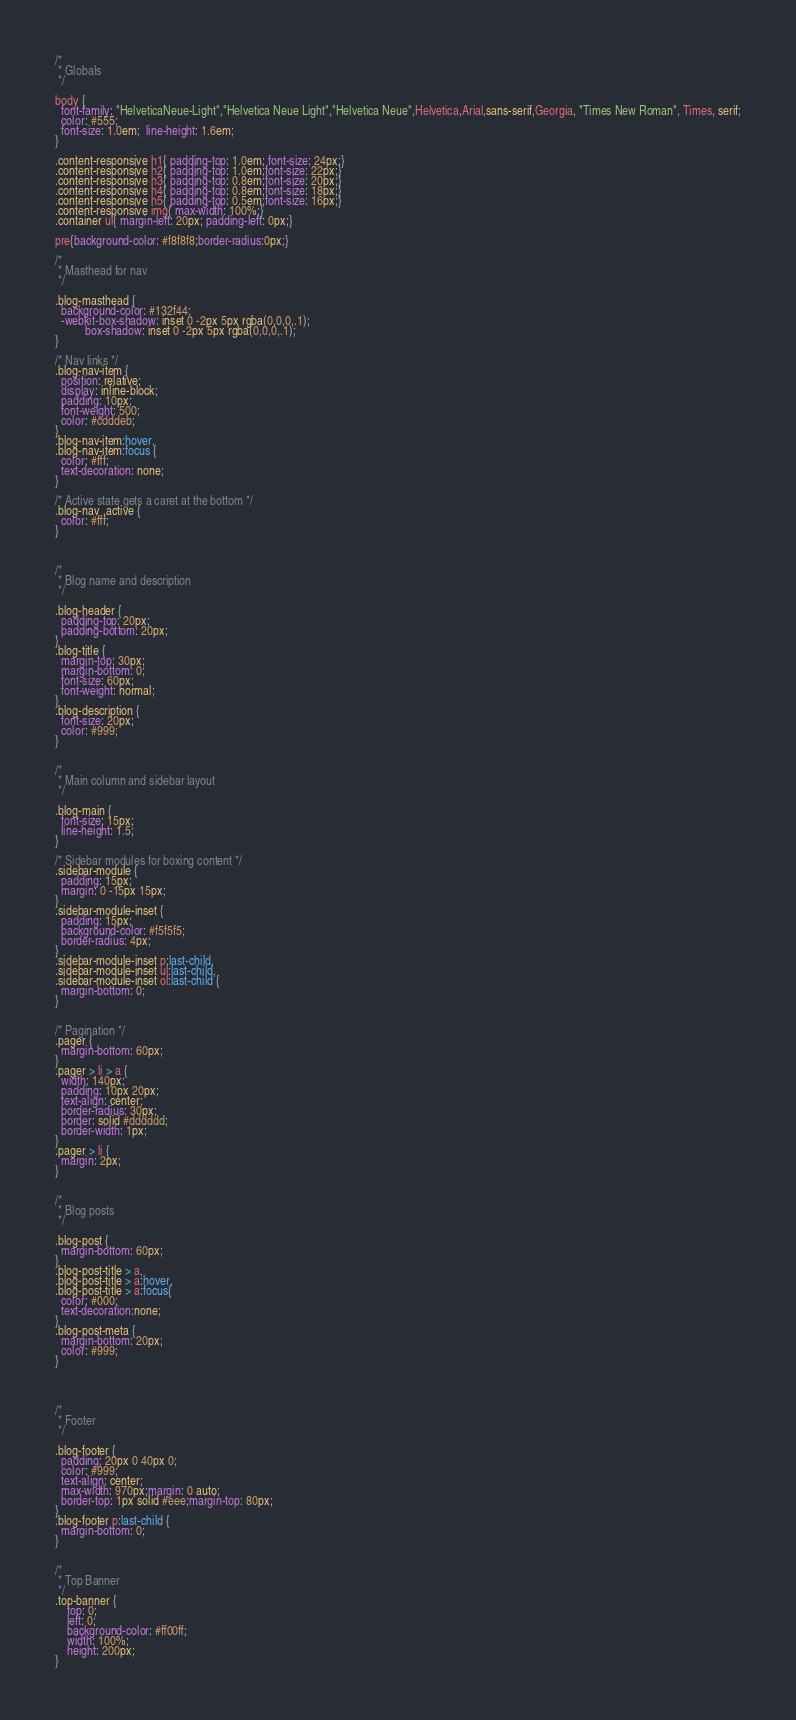<code> <loc_0><loc_0><loc_500><loc_500><_CSS_>
/*
 * Globals
 */

body {
  font-family: "HelveticaNeue-Light","Helvetica Neue Light","Helvetica Neue",Helvetica,Arial,sans-serif,Georgia, "Times New Roman", Times, serif;
  color: #555;
  font-size: 1.0em;  line-height: 1.6em;
}

.content-responsive h1{ padding-top: 1.0em; font-size: 24px;}
.content-responsive h2{ padding-top: 1.0em;font-size: 22px;}
.content-responsive h3{ padding-top: 0.8em;font-size: 20px;}
.content-responsive h4{ padding-top: 0.8em;font-size: 18px;}
.content-responsive h5{ padding-top: 0.5em;font-size: 16px;}
.content-responsive img{ max-width: 100%;}
.container ul{ margin-left: 20px; padding-left: 0px;}

pre{background-color: #f8f8f8;border-radius:0px;}   

/*
 * Masthead for nav
 */

.blog-masthead {
  background-color: #132f44;
  -webkit-box-shadow: inset 0 -2px 5px rgba(0,0,0,.1);
          box-shadow: inset 0 -2px 5px rgba(0,0,0,.1);
}

/* Nav links */
.blog-nav-item {
  position: relative;
  display: inline-block;
  padding: 10px;
  font-weight: 500;
  color: #cdddeb;
}
.blog-nav-item:hover,
.blog-nav-item:focus {
  color: #fff;
  text-decoration: none;
}

/* Active state gets a caret at the bottom */
.blog-nav .active {
  color: #fff;
}



/*
 * Blog name and description
 */

.blog-header {
  padding-top: 20px;
  padding-bottom: 20px;
}
.blog-title {
  margin-top: 30px;
  margin-bottom: 0;
  font-size: 60px;
  font-weight: normal;
}
.blog-description {
  font-size: 20px;
  color: #999;
}


/*
 * Main column and sidebar layout
 */

.blog-main {
  font-size: 15px;
  line-height: 1.5;
}

/* Sidebar modules for boxing content */
.sidebar-module {
  padding: 15px;
  margin: 0 -15px 15px;
}
.sidebar-module-inset {
  padding: 15px;
  background-color: #f5f5f5;
  border-radius: 4px;
}
.sidebar-module-inset p:last-child,
.sidebar-module-inset ul:last-child,
.sidebar-module-inset ol:last-child {
  margin-bottom: 0;
}


/* Pagination */
.pager {
  margin-bottom: 60px;
}
.pager > li > a {
  width: 140px;
  padding: 10px 20px;
  text-align: center;
  border-radius: 30px;
  border: solid #dddddd;
  border-width: 1px;
}
.pager > li {
  margin: 2px;
}


/*
 * Blog posts
 */

.blog-post {
  margin-bottom: 60px;
}
.blog-post-title > a,
.blog-post-title > a:hover,
.blog-post-title > a:focus{
  color: #000;
  text-decoration:none;
}
.blog-post-meta {
  margin-bottom: 20px;
  color: #999;
}




/*
 * Footer
 */

.blog-footer {
  padding: 20px 0 40px 0;
  color: #999;
  text-align: center;
  max-width: 970px;margin: 0 auto;
  border-top: 1px solid #eee;margin-top: 80px;
}
.blog-footer p:last-child {
  margin-bottom: 0;
}


/*
 * Top Banner
 */
.top-banner {
    top: 0;
    left: 0;
    background-color: #ff00ff;
    width: 100%;
    height: 200px;
}



</code> 